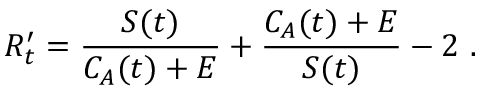<formula> <loc_0><loc_0><loc_500><loc_500>R _ { t } ^ { \prime } = \frac { S ( t ) } { C _ { A } ( t ) + E } + \frac { C _ { A } ( t ) + E } { S ( t ) } - 2 \ .</formula> 